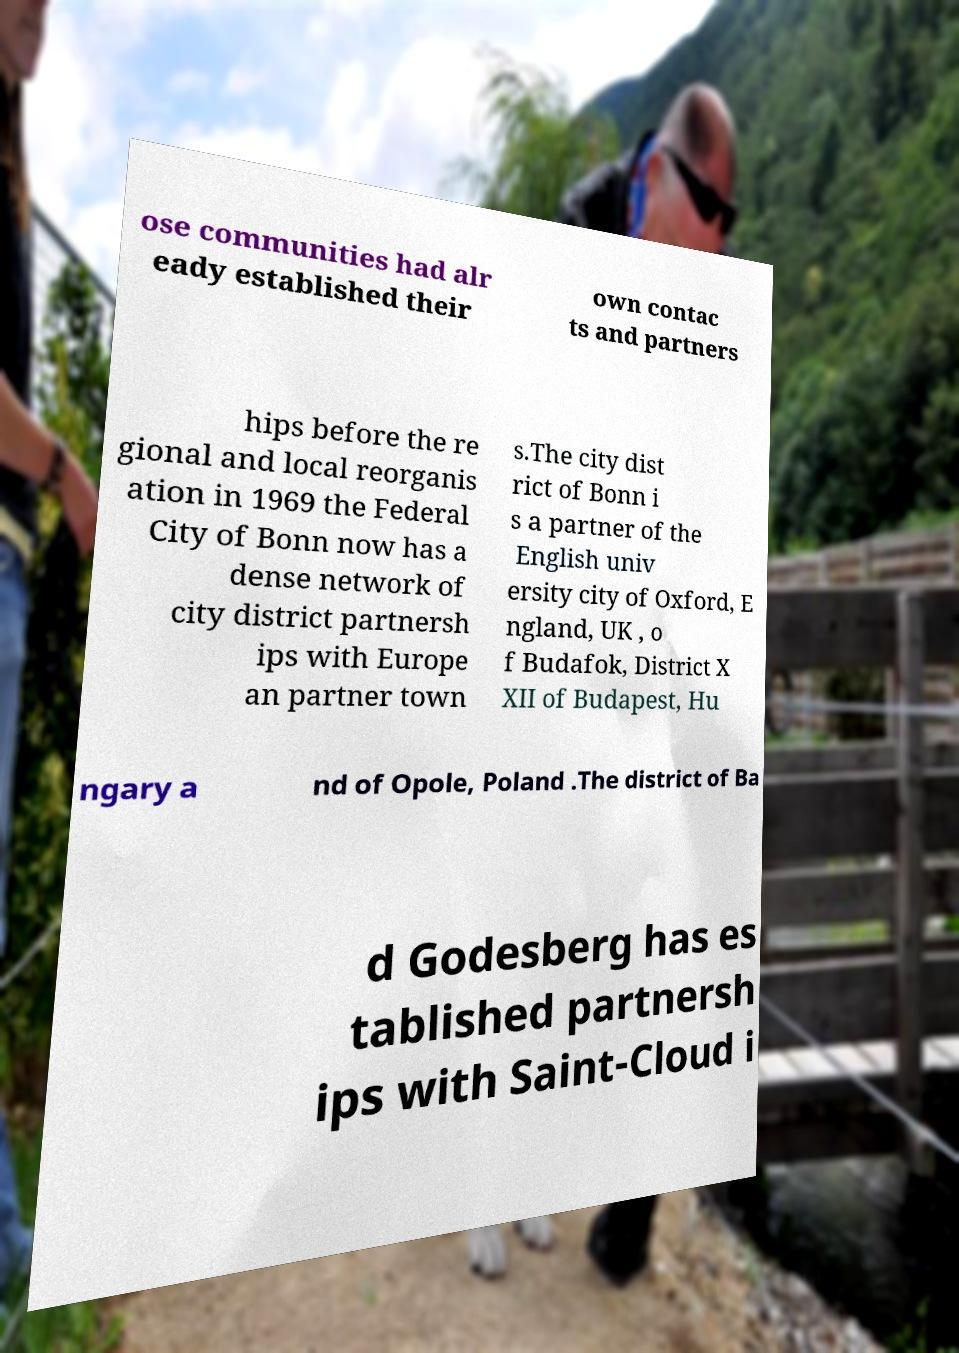Can you accurately transcribe the text from the provided image for me? ose communities had alr eady established their own contac ts and partners hips before the re gional and local reorganis ation in 1969 the Federal City of Bonn now has a dense network of city district partnersh ips with Europe an partner town s.The city dist rict of Bonn i s a partner of the English univ ersity city of Oxford, E ngland, UK , o f Budafok, District X XII of Budapest, Hu ngary a nd of Opole, Poland .The district of Ba d Godesberg has es tablished partnersh ips with Saint-Cloud i 